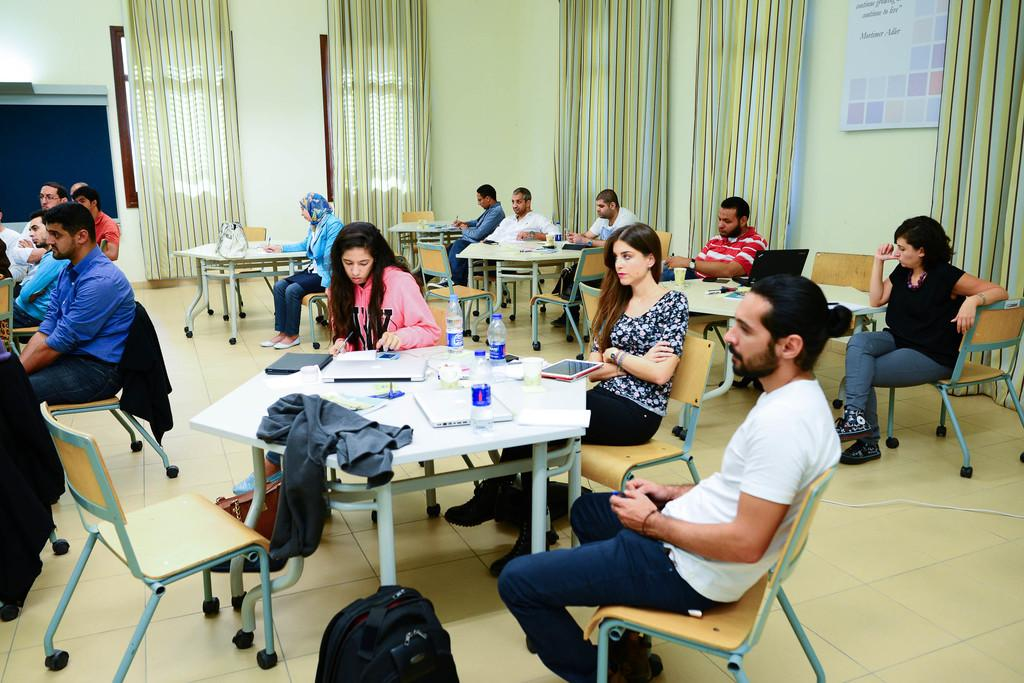Who is present in the image? There are people in the image. What are the people doing in the image? The people are sitting at tables. What might the people be listening to while sitting at the tables? The people are listening to something. What type of office furniture can be seen in the image? There is no mention of an office or office furniture in the provided facts, so we cannot answer this question based on the image. 